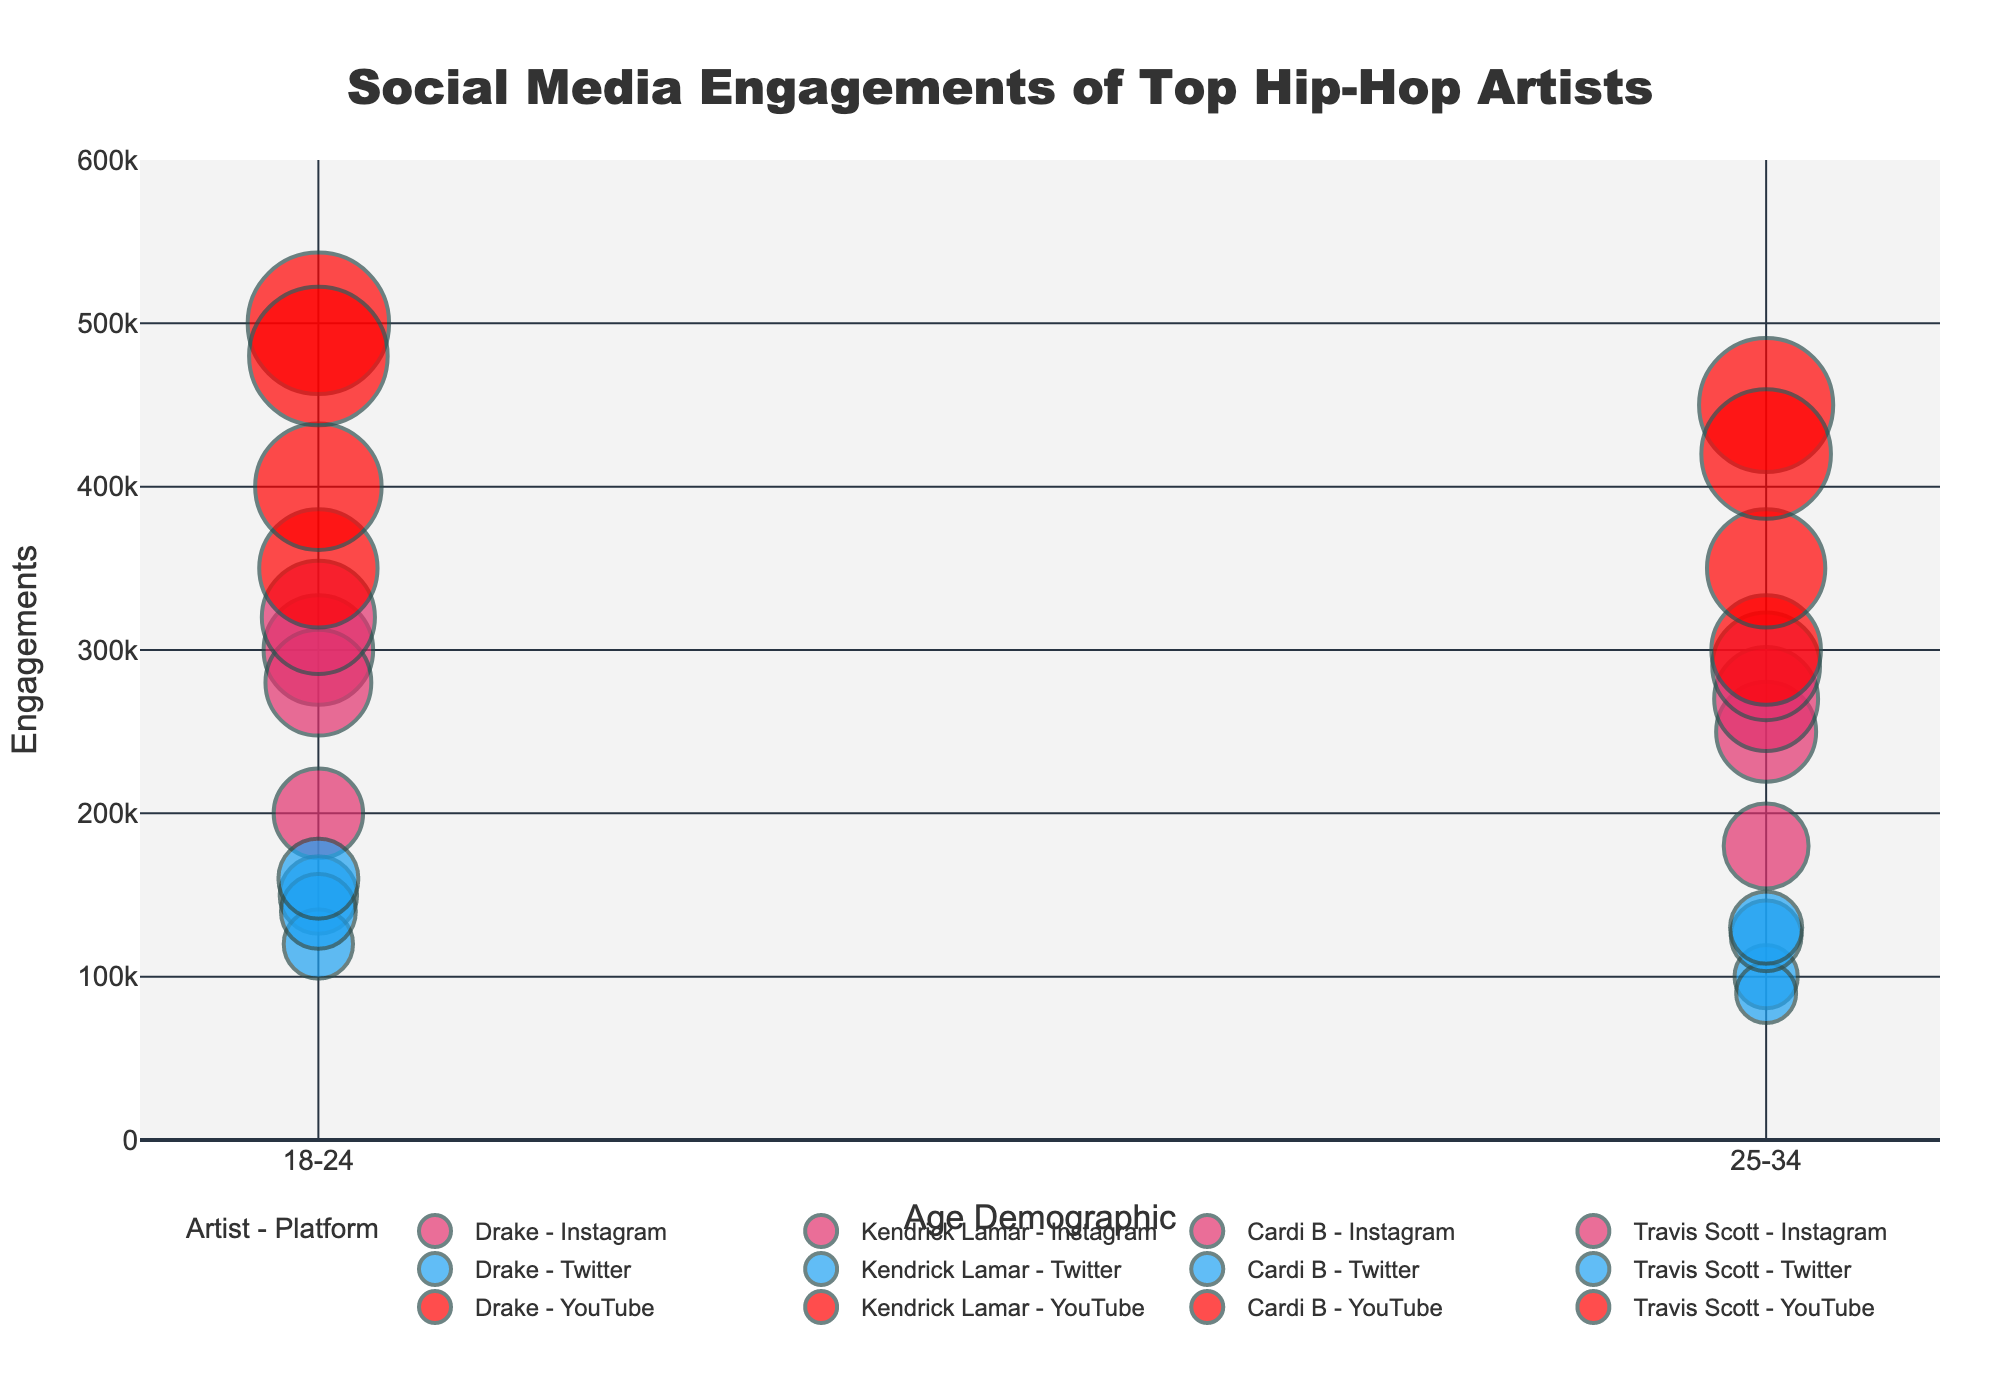Which platform has the highest engagement for the 18-24 age demographic? To determine the platform with the highest engagement for the 18-24 age demographic, look at the bubble associated with each platform and artist combination within that age group. The largest bubble would indicate the highest engagement. Travis Scott's YouTube engagement for 18-24 is 480,000, which is the highest.
Answer: YouTube Which artist has the highest engagement on Instagram for the 25-34 demographic? We need to find the bubbles representing Instagram engagements for each artist in the 25-34 age demographic. By comparing them, we see that Travis Scott has the highest engagement with 290,000.
Answer: Travis Scott Who has more Twitter engagements in the 18-24 demographic, Drake or Cardi B? Compare the bubble size (representing engagements) for Drake and Cardi B on Twitter within the 18-24 age demographic. Drake has 150,000 engagements, and Cardi B has 140,000 engagements. Therefore, Drake has more.
Answer: Drake What is the combined engagement of Kendrick Lamar across all platforms for the 25-34 demographic? Sum up the engagements of Kendrick Lamar in the 25-34 demographic across all platforms: Instagram (180,000) + Twitter (90,000) + YouTube (300,000) = 570,000.
Answer: 570,000 Which artist and platform combination has the smallest engagement in the 25-34 demographic? Identify the smallest bubble in the 25-34 demographic. Comparing them, Kendrick Lamar on Twitter has the smallest engagement with 90,000.
Answer: Kendrick Lamar - Twitter How do the engagements of Drake and Travis Scott on YouTube for the 18-24 demographic compare? Compare the size of the bubbles for Drake and Travis Scott on YouTube in the 18-24 demographic. Drake has 500,000 engagements, while Travis Scott has 480,000 engagements. Drake has slightly more engagements.
Answer: Drake has more What is the average engagement on Instagram for the 18-24 age demographic across all artists? Sum the engagements for all artists on Instagram in the 18-24 demographic and divide by the number of artists: (Drake 300,000 + Kendrick Lamar 200,000 + Cardi B 280,000 + Travis Scott 320,000) / 4 = 1,100,000 / 4 = 275,000.
Answer: 275,000 Which artist has the highest total engagement across all platforms and demographics? Sum the engagements for each artist across all platforms and demographics, then compare. Drake: 2,100,000; Kendrick Lamar: 1,240,000; Cardi B: 1,565,000; Travis Scott: 1,800,000. Drake has the highest total engagements.
Answer: Drake Which demographic has the lowest engagement for Cardi B on YouTube and what is that number? Compare the engagements for Cardi B on YouTube across the 18-24 and 25-34 demographics. The 25-34 demographic has 350,000, which is lower than the 18-24 demographic with 400,000.
Answer: 25-34 with 350,000 